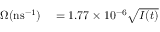Convert formula to latex. <formula><loc_0><loc_0><loc_500><loc_500>\begin{array} { r l } { \Omega ( n s ^ { - 1 } ) } & = 1 . 7 7 \times 1 0 ^ { - 6 } \sqrt { I ( t ) } } \end{array}</formula> 